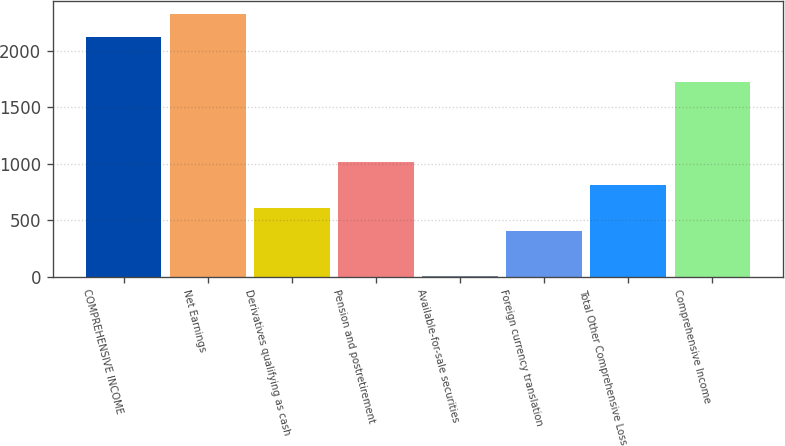<chart> <loc_0><loc_0><loc_500><loc_500><bar_chart><fcel>COMPREHENSIVE INCOME<fcel>Net Earnings<fcel>Derivatives qualifying as cash<fcel>Pension and postretirement<fcel>Available-for-sale securities<fcel>Foreign currency translation<fcel>Total Other Comprehensive Loss<fcel>Comprehensive Income<nl><fcel>2125.2<fcel>2327.8<fcel>610.8<fcel>1016<fcel>3<fcel>408.2<fcel>813.4<fcel>1720<nl></chart> 